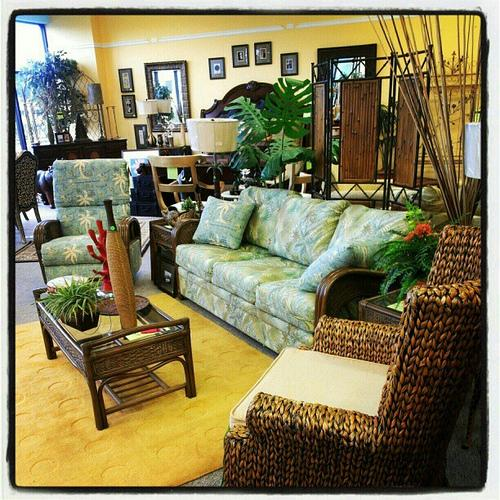Describe the appearance and color of the rug that's in the image. The rug is a thick, yellow rug with circles on it, covering a large portion of the floor. List the objects present in the image that involve plants or flowers. Objects include a tall fake plant, fake flower on a table, green plant in a pot, green leaf plant in a dark brown planter, and a large potted palm. Is there any object in the image that could be used to divide a room? Yes, there is a black metal and bamboo screen that could be used to divide a room. Count the number of chairs visible in the image. There are four visible chairs in the image, including a wood chair and tropical-printed chairs. Identify what type of furniture is abundant in the image. Woven wicker furniture and pieces with tropical prints are abundant in the image. Mention the type of wall decorations present in the image. There are pictures hanging on the wall, a mirror in a frame, a rectangular mirror, a framed mirror, and square picture above a bed. How many lamps with white shades are visible in the image? There are two lamps with white shades visible in the image. What kind of decorative item is on the coffee table? There is a potted plant and other decorations on the coffee table. Give a brief description of the room's ambiance and overall sentiment based on the objects present in the image. The room has a cozy and tropical ambiance with wicker furniture, palm tree prints, and numerous plants creating a relaxing environment. Explain the relationship and interaction between the couch, coffee table, and rug. The couch, coffee table, and rug are arranged in a living room setting where the rug is spread on the floor, and the coffee table is placed in front of the couch on top of the rug. 